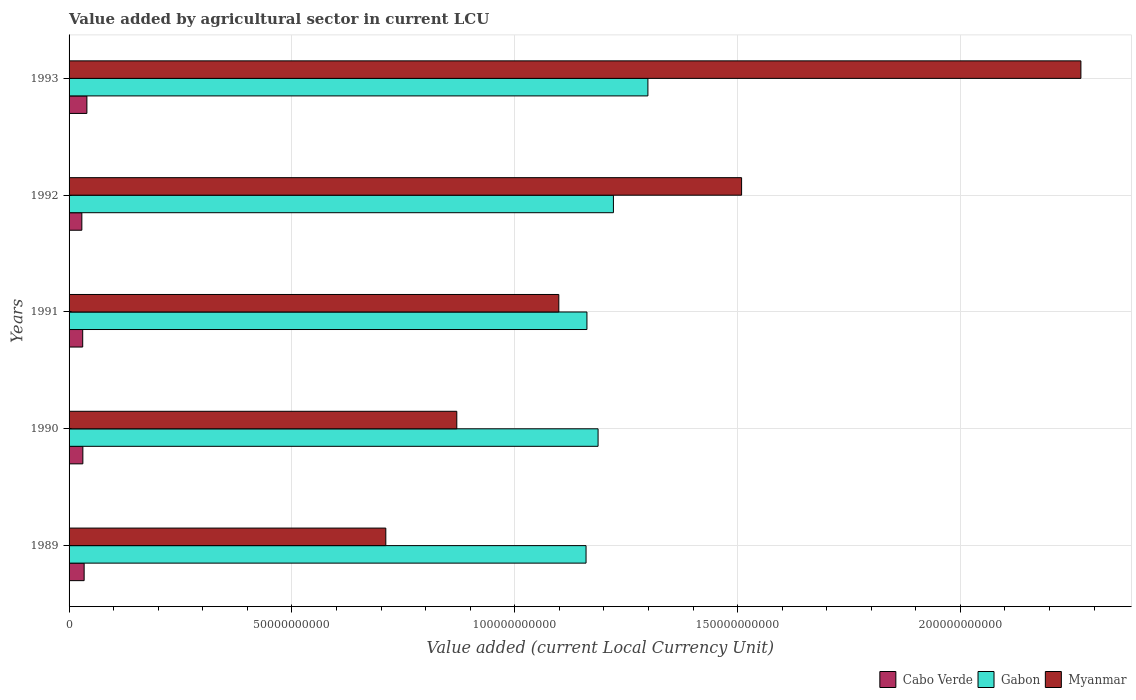How many different coloured bars are there?
Keep it short and to the point. 3. How many bars are there on the 5th tick from the top?
Make the answer very short. 3. How many bars are there on the 3rd tick from the bottom?
Offer a very short reply. 3. What is the value added by agricultural sector in Myanmar in 1991?
Your answer should be very brief. 1.10e+11. Across all years, what is the maximum value added by agricultural sector in Cabo Verde?
Offer a very short reply. 4.00e+09. Across all years, what is the minimum value added by agricultural sector in Myanmar?
Ensure brevity in your answer.  7.11e+1. In which year was the value added by agricultural sector in Cabo Verde maximum?
Provide a short and direct response. 1993. What is the total value added by agricultural sector in Myanmar in the graph?
Ensure brevity in your answer.  6.46e+11. What is the difference between the value added by agricultural sector in Cabo Verde in 1989 and that in 1990?
Keep it short and to the point. 2.88e+08. What is the difference between the value added by agricultural sector in Gabon in 1993 and the value added by agricultural sector in Cabo Verde in 1989?
Offer a very short reply. 1.26e+11. What is the average value added by agricultural sector in Cabo Verde per year?
Your response must be concise. 3.28e+09. In the year 1989, what is the difference between the value added by agricultural sector in Gabon and value added by agricultural sector in Cabo Verde?
Ensure brevity in your answer.  1.13e+11. What is the ratio of the value added by agricultural sector in Cabo Verde in 1992 to that in 1993?
Make the answer very short. 0.72. Is the value added by agricultural sector in Cabo Verde in 1989 less than that in 1993?
Give a very brief answer. Yes. Is the difference between the value added by agricultural sector in Gabon in 1990 and 1993 greater than the difference between the value added by agricultural sector in Cabo Verde in 1990 and 1993?
Provide a short and direct response. No. What is the difference between the highest and the second highest value added by agricultural sector in Cabo Verde?
Provide a succinct answer. 6.17e+08. What is the difference between the highest and the lowest value added by agricultural sector in Gabon?
Ensure brevity in your answer.  1.39e+1. Is the sum of the value added by agricultural sector in Cabo Verde in 1992 and 1993 greater than the maximum value added by agricultural sector in Myanmar across all years?
Provide a short and direct response. No. What does the 3rd bar from the top in 1991 represents?
Offer a very short reply. Cabo Verde. What does the 3rd bar from the bottom in 1991 represents?
Your response must be concise. Myanmar. Is it the case that in every year, the sum of the value added by agricultural sector in Cabo Verde and value added by agricultural sector in Myanmar is greater than the value added by agricultural sector in Gabon?
Make the answer very short. No. Are all the bars in the graph horizontal?
Offer a very short reply. Yes. Are the values on the major ticks of X-axis written in scientific E-notation?
Your response must be concise. No. Does the graph contain any zero values?
Keep it short and to the point. No. How are the legend labels stacked?
Offer a very short reply. Horizontal. What is the title of the graph?
Offer a terse response. Value added by agricultural sector in current LCU. Does "South Sudan" appear as one of the legend labels in the graph?
Your answer should be compact. No. What is the label or title of the X-axis?
Ensure brevity in your answer.  Value added (current Local Currency Unit). What is the label or title of the Y-axis?
Provide a succinct answer. Years. What is the Value added (current Local Currency Unit) in Cabo Verde in 1989?
Offer a very short reply. 3.38e+09. What is the Value added (current Local Currency Unit) in Gabon in 1989?
Offer a terse response. 1.16e+11. What is the Value added (current Local Currency Unit) of Myanmar in 1989?
Keep it short and to the point. 7.11e+1. What is the Value added (current Local Currency Unit) in Cabo Verde in 1990?
Provide a succinct answer. 3.09e+09. What is the Value added (current Local Currency Unit) in Gabon in 1990?
Offer a terse response. 1.19e+11. What is the Value added (current Local Currency Unit) in Myanmar in 1990?
Offer a very short reply. 8.70e+1. What is the Value added (current Local Currency Unit) of Cabo Verde in 1991?
Keep it short and to the point. 3.06e+09. What is the Value added (current Local Currency Unit) in Gabon in 1991?
Make the answer very short. 1.16e+11. What is the Value added (current Local Currency Unit) of Myanmar in 1991?
Ensure brevity in your answer.  1.10e+11. What is the Value added (current Local Currency Unit) of Cabo Verde in 1992?
Offer a very short reply. 2.87e+09. What is the Value added (current Local Currency Unit) of Gabon in 1992?
Provide a succinct answer. 1.22e+11. What is the Value added (current Local Currency Unit) in Myanmar in 1992?
Give a very brief answer. 1.51e+11. What is the Value added (current Local Currency Unit) of Cabo Verde in 1993?
Offer a very short reply. 4.00e+09. What is the Value added (current Local Currency Unit) of Gabon in 1993?
Your answer should be compact. 1.30e+11. What is the Value added (current Local Currency Unit) of Myanmar in 1993?
Your answer should be very brief. 2.27e+11. Across all years, what is the maximum Value added (current Local Currency Unit) of Cabo Verde?
Your answer should be very brief. 4.00e+09. Across all years, what is the maximum Value added (current Local Currency Unit) in Gabon?
Your response must be concise. 1.30e+11. Across all years, what is the maximum Value added (current Local Currency Unit) of Myanmar?
Your response must be concise. 2.27e+11. Across all years, what is the minimum Value added (current Local Currency Unit) in Cabo Verde?
Give a very brief answer. 2.87e+09. Across all years, what is the minimum Value added (current Local Currency Unit) of Gabon?
Give a very brief answer. 1.16e+11. Across all years, what is the minimum Value added (current Local Currency Unit) in Myanmar?
Give a very brief answer. 7.11e+1. What is the total Value added (current Local Currency Unit) of Cabo Verde in the graph?
Your response must be concise. 1.64e+1. What is the total Value added (current Local Currency Unit) of Gabon in the graph?
Offer a terse response. 6.03e+11. What is the total Value added (current Local Currency Unit) in Myanmar in the graph?
Ensure brevity in your answer.  6.46e+11. What is the difference between the Value added (current Local Currency Unit) in Cabo Verde in 1989 and that in 1990?
Your answer should be very brief. 2.88e+08. What is the difference between the Value added (current Local Currency Unit) in Gabon in 1989 and that in 1990?
Your answer should be compact. -2.70e+09. What is the difference between the Value added (current Local Currency Unit) in Myanmar in 1989 and that in 1990?
Make the answer very short. -1.59e+1. What is the difference between the Value added (current Local Currency Unit) of Cabo Verde in 1989 and that in 1991?
Your answer should be very brief. 3.22e+08. What is the difference between the Value added (current Local Currency Unit) in Gabon in 1989 and that in 1991?
Offer a terse response. -2.00e+08. What is the difference between the Value added (current Local Currency Unit) of Myanmar in 1989 and that in 1991?
Offer a terse response. -3.88e+1. What is the difference between the Value added (current Local Currency Unit) of Cabo Verde in 1989 and that in 1992?
Your answer should be compact. 5.16e+08. What is the difference between the Value added (current Local Currency Unit) of Gabon in 1989 and that in 1992?
Make the answer very short. -6.14e+09. What is the difference between the Value added (current Local Currency Unit) in Myanmar in 1989 and that in 1992?
Your answer should be very brief. -7.98e+1. What is the difference between the Value added (current Local Currency Unit) of Cabo Verde in 1989 and that in 1993?
Offer a terse response. -6.17e+08. What is the difference between the Value added (current Local Currency Unit) in Gabon in 1989 and that in 1993?
Make the answer very short. -1.39e+1. What is the difference between the Value added (current Local Currency Unit) of Myanmar in 1989 and that in 1993?
Offer a very short reply. -1.56e+11. What is the difference between the Value added (current Local Currency Unit) of Cabo Verde in 1990 and that in 1991?
Give a very brief answer. 3.41e+07. What is the difference between the Value added (current Local Currency Unit) of Gabon in 1990 and that in 1991?
Offer a terse response. 2.50e+09. What is the difference between the Value added (current Local Currency Unit) in Myanmar in 1990 and that in 1991?
Your answer should be very brief. -2.29e+1. What is the difference between the Value added (current Local Currency Unit) in Cabo Verde in 1990 and that in 1992?
Your answer should be compact. 2.28e+08. What is the difference between the Value added (current Local Currency Unit) in Gabon in 1990 and that in 1992?
Offer a very short reply. -3.44e+09. What is the difference between the Value added (current Local Currency Unit) in Myanmar in 1990 and that in 1992?
Ensure brevity in your answer.  -6.39e+1. What is the difference between the Value added (current Local Currency Unit) of Cabo Verde in 1990 and that in 1993?
Make the answer very short. -9.05e+08. What is the difference between the Value added (current Local Currency Unit) of Gabon in 1990 and that in 1993?
Provide a succinct answer. -1.12e+1. What is the difference between the Value added (current Local Currency Unit) in Myanmar in 1990 and that in 1993?
Ensure brevity in your answer.  -1.40e+11. What is the difference between the Value added (current Local Currency Unit) of Cabo Verde in 1991 and that in 1992?
Make the answer very short. 1.94e+08. What is the difference between the Value added (current Local Currency Unit) in Gabon in 1991 and that in 1992?
Ensure brevity in your answer.  -5.94e+09. What is the difference between the Value added (current Local Currency Unit) in Myanmar in 1991 and that in 1992?
Make the answer very short. -4.10e+1. What is the difference between the Value added (current Local Currency Unit) in Cabo Verde in 1991 and that in 1993?
Your answer should be very brief. -9.39e+08. What is the difference between the Value added (current Local Currency Unit) of Gabon in 1991 and that in 1993?
Offer a very short reply. -1.37e+1. What is the difference between the Value added (current Local Currency Unit) of Myanmar in 1991 and that in 1993?
Offer a very short reply. -1.17e+11. What is the difference between the Value added (current Local Currency Unit) in Cabo Verde in 1992 and that in 1993?
Your response must be concise. -1.13e+09. What is the difference between the Value added (current Local Currency Unit) in Gabon in 1992 and that in 1993?
Offer a very short reply. -7.74e+09. What is the difference between the Value added (current Local Currency Unit) in Myanmar in 1992 and that in 1993?
Offer a terse response. -7.61e+1. What is the difference between the Value added (current Local Currency Unit) of Cabo Verde in 1989 and the Value added (current Local Currency Unit) of Gabon in 1990?
Provide a short and direct response. -1.15e+11. What is the difference between the Value added (current Local Currency Unit) in Cabo Verde in 1989 and the Value added (current Local Currency Unit) in Myanmar in 1990?
Keep it short and to the point. -8.36e+1. What is the difference between the Value added (current Local Currency Unit) in Gabon in 1989 and the Value added (current Local Currency Unit) in Myanmar in 1990?
Provide a succinct answer. 2.90e+1. What is the difference between the Value added (current Local Currency Unit) of Cabo Verde in 1989 and the Value added (current Local Currency Unit) of Gabon in 1991?
Make the answer very short. -1.13e+11. What is the difference between the Value added (current Local Currency Unit) in Cabo Verde in 1989 and the Value added (current Local Currency Unit) in Myanmar in 1991?
Keep it short and to the point. -1.07e+11. What is the difference between the Value added (current Local Currency Unit) of Gabon in 1989 and the Value added (current Local Currency Unit) of Myanmar in 1991?
Offer a terse response. 6.11e+09. What is the difference between the Value added (current Local Currency Unit) of Cabo Verde in 1989 and the Value added (current Local Currency Unit) of Gabon in 1992?
Provide a short and direct response. -1.19e+11. What is the difference between the Value added (current Local Currency Unit) in Cabo Verde in 1989 and the Value added (current Local Currency Unit) in Myanmar in 1992?
Provide a short and direct response. -1.48e+11. What is the difference between the Value added (current Local Currency Unit) of Gabon in 1989 and the Value added (current Local Currency Unit) of Myanmar in 1992?
Offer a very short reply. -3.49e+1. What is the difference between the Value added (current Local Currency Unit) in Cabo Verde in 1989 and the Value added (current Local Currency Unit) in Gabon in 1993?
Make the answer very short. -1.26e+11. What is the difference between the Value added (current Local Currency Unit) of Cabo Verde in 1989 and the Value added (current Local Currency Unit) of Myanmar in 1993?
Your answer should be compact. -2.24e+11. What is the difference between the Value added (current Local Currency Unit) in Gabon in 1989 and the Value added (current Local Currency Unit) in Myanmar in 1993?
Offer a very short reply. -1.11e+11. What is the difference between the Value added (current Local Currency Unit) in Cabo Verde in 1990 and the Value added (current Local Currency Unit) in Gabon in 1991?
Provide a succinct answer. -1.13e+11. What is the difference between the Value added (current Local Currency Unit) of Cabo Verde in 1990 and the Value added (current Local Currency Unit) of Myanmar in 1991?
Offer a terse response. -1.07e+11. What is the difference between the Value added (current Local Currency Unit) of Gabon in 1990 and the Value added (current Local Currency Unit) of Myanmar in 1991?
Keep it short and to the point. 8.81e+09. What is the difference between the Value added (current Local Currency Unit) of Cabo Verde in 1990 and the Value added (current Local Currency Unit) of Gabon in 1992?
Your response must be concise. -1.19e+11. What is the difference between the Value added (current Local Currency Unit) in Cabo Verde in 1990 and the Value added (current Local Currency Unit) in Myanmar in 1992?
Provide a short and direct response. -1.48e+11. What is the difference between the Value added (current Local Currency Unit) of Gabon in 1990 and the Value added (current Local Currency Unit) of Myanmar in 1992?
Your response must be concise. -3.22e+1. What is the difference between the Value added (current Local Currency Unit) of Cabo Verde in 1990 and the Value added (current Local Currency Unit) of Gabon in 1993?
Your response must be concise. -1.27e+11. What is the difference between the Value added (current Local Currency Unit) of Cabo Verde in 1990 and the Value added (current Local Currency Unit) of Myanmar in 1993?
Offer a terse response. -2.24e+11. What is the difference between the Value added (current Local Currency Unit) of Gabon in 1990 and the Value added (current Local Currency Unit) of Myanmar in 1993?
Provide a short and direct response. -1.08e+11. What is the difference between the Value added (current Local Currency Unit) of Cabo Verde in 1991 and the Value added (current Local Currency Unit) of Gabon in 1992?
Your answer should be very brief. -1.19e+11. What is the difference between the Value added (current Local Currency Unit) of Cabo Verde in 1991 and the Value added (current Local Currency Unit) of Myanmar in 1992?
Offer a terse response. -1.48e+11. What is the difference between the Value added (current Local Currency Unit) in Gabon in 1991 and the Value added (current Local Currency Unit) in Myanmar in 1992?
Ensure brevity in your answer.  -3.47e+1. What is the difference between the Value added (current Local Currency Unit) in Cabo Verde in 1991 and the Value added (current Local Currency Unit) in Gabon in 1993?
Give a very brief answer. -1.27e+11. What is the difference between the Value added (current Local Currency Unit) of Cabo Verde in 1991 and the Value added (current Local Currency Unit) of Myanmar in 1993?
Provide a short and direct response. -2.24e+11. What is the difference between the Value added (current Local Currency Unit) of Gabon in 1991 and the Value added (current Local Currency Unit) of Myanmar in 1993?
Ensure brevity in your answer.  -1.11e+11. What is the difference between the Value added (current Local Currency Unit) of Cabo Verde in 1992 and the Value added (current Local Currency Unit) of Gabon in 1993?
Keep it short and to the point. -1.27e+11. What is the difference between the Value added (current Local Currency Unit) of Cabo Verde in 1992 and the Value added (current Local Currency Unit) of Myanmar in 1993?
Give a very brief answer. -2.24e+11. What is the difference between the Value added (current Local Currency Unit) in Gabon in 1992 and the Value added (current Local Currency Unit) in Myanmar in 1993?
Your answer should be very brief. -1.05e+11. What is the average Value added (current Local Currency Unit) in Cabo Verde per year?
Provide a succinct answer. 3.28e+09. What is the average Value added (current Local Currency Unit) of Gabon per year?
Ensure brevity in your answer.  1.21e+11. What is the average Value added (current Local Currency Unit) in Myanmar per year?
Provide a succinct answer. 1.29e+11. In the year 1989, what is the difference between the Value added (current Local Currency Unit) in Cabo Verde and Value added (current Local Currency Unit) in Gabon?
Make the answer very short. -1.13e+11. In the year 1989, what is the difference between the Value added (current Local Currency Unit) of Cabo Verde and Value added (current Local Currency Unit) of Myanmar?
Ensure brevity in your answer.  -6.77e+1. In the year 1989, what is the difference between the Value added (current Local Currency Unit) in Gabon and Value added (current Local Currency Unit) in Myanmar?
Make the answer very short. 4.49e+1. In the year 1990, what is the difference between the Value added (current Local Currency Unit) of Cabo Verde and Value added (current Local Currency Unit) of Gabon?
Ensure brevity in your answer.  -1.16e+11. In the year 1990, what is the difference between the Value added (current Local Currency Unit) in Cabo Verde and Value added (current Local Currency Unit) in Myanmar?
Your answer should be compact. -8.39e+1. In the year 1990, what is the difference between the Value added (current Local Currency Unit) in Gabon and Value added (current Local Currency Unit) in Myanmar?
Provide a short and direct response. 3.17e+1. In the year 1991, what is the difference between the Value added (current Local Currency Unit) in Cabo Verde and Value added (current Local Currency Unit) in Gabon?
Your response must be concise. -1.13e+11. In the year 1991, what is the difference between the Value added (current Local Currency Unit) of Cabo Verde and Value added (current Local Currency Unit) of Myanmar?
Give a very brief answer. -1.07e+11. In the year 1991, what is the difference between the Value added (current Local Currency Unit) of Gabon and Value added (current Local Currency Unit) of Myanmar?
Offer a terse response. 6.31e+09. In the year 1992, what is the difference between the Value added (current Local Currency Unit) in Cabo Verde and Value added (current Local Currency Unit) in Gabon?
Your response must be concise. -1.19e+11. In the year 1992, what is the difference between the Value added (current Local Currency Unit) in Cabo Verde and Value added (current Local Currency Unit) in Myanmar?
Your answer should be very brief. -1.48e+11. In the year 1992, what is the difference between the Value added (current Local Currency Unit) in Gabon and Value added (current Local Currency Unit) in Myanmar?
Provide a succinct answer. -2.88e+1. In the year 1993, what is the difference between the Value added (current Local Currency Unit) in Cabo Verde and Value added (current Local Currency Unit) in Gabon?
Keep it short and to the point. -1.26e+11. In the year 1993, what is the difference between the Value added (current Local Currency Unit) in Cabo Verde and Value added (current Local Currency Unit) in Myanmar?
Your answer should be very brief. -2.23e+11. In the year 1993, what is the difference between the Value added (current Local Currency Unit) of Gabon and Value added (current Local Currency Unit) of Myanmar?
Ensure brevity in your answer.  -9.72e+1. What is the ratio of the Value added (current Local Currency Unit) of Cabo Verde in 1989 to that in 1990?
Offer a terse response. 1.09. What is the ratio of the Value added (current Local Currency Unit) in Gabon in 1989 to that in 1990?
Ensure brevity in your answer.  0.98. What is the ratio of the Value added (current Local Currency Unit) in Myanmar in 1989 to that in 1990?
Your answer should be very brief. 0.82. What is the ratio of the Value added (current Local Currency Unit) of Cabo Verde in 1989 to that in 1991?
Ensure brevity in your answer.  1.11. What is the ratio of the Value added (current Local Currency Unit) of Myanmar in 1989 to that in 1991?
Your answer should be very brief. 0.65. What is the ratio of the Value added (current Local Currency Unit) in Cabo Verde in 1989 to that in 1992?
Provide a short and direct response. 1.18. What is the ratio of the Value added (current Local Currency Unit) in Gabon in 1989 to that in 1992?
Your answer should be very brief. 0.95. What is the ratio of the Value added (current Local Currency Unit) in Myanmar in 1989 to that in 1992?
Give a very brief answer. 0.47. What is the ratio of the Value added (current Local Currency Unit) in Cabo Verde in 1989 to that in 1993?
Provide a short and direct response. 0.85. What is the ratio of the Value added (current Local Currency Unit) in Gabon in 1989 to that in 1993?
Offer a terse response. 0.89. What is the ratio of the Value added (current Local Currency Unit) in Myanmar in 1989 to that in 1993?
Give a very brief answer. 0.31. What is the ratio of the Value added (current Local Currency Unit) of Cabo Verde in 1990 to that in 1991?
Give a very brief answer. 1.01. What is the ratio of the Value added (current Local Currency Unit) of Gabon in 1990 to that in 1991?
Make the answer very short. 1.02. What is the ratio of the Value added (current Local Currency Unit) of Myanmar in 1990 to that in 1991?
Keep it short and to the point. 0.79. What is the ratio of the Value added (current Local Currency Unit) of Cabo Verde in 1990 to that in 1992?
Offer a terse response. 1.08. What is the ratio of the Value added (current Local Currency Unit) of Gabon in 1990 to that in 1992?
Offer a terse response. 0.97. What is the ratio of the Value added (current Local Currency Unit) in Myanmar in 1990 to that in 1992?
Make the answer very short. 0.58. What is the ratio of the Value added (current Local Currency Unit) in Cabo Verde in 1990 to that in 1993?
Ensure brevity in your answer.  0.77. What is the ratio of the Value added (current Local Currency Unit) of Gabon in 1990 to that in 1993?
Give a very brief answer. 0.91. What is the ratio of the Value added (current Local Currency Unit) in Myanmar in 1990 to that in 1993?
Provide a short and direct response. 0.38. What is the ratio of the Value added (current Local Currency Unit) of Cabo Verde in 1991 to that in 1992?
Ensure brevity in your answer.  1.07. What is the ratio of the Value added (current Local Currency Unit) in Gabon in 1991 to that in 1992?
Your answer should be compact. 0.95. What is the ratio of the Value added (current Local Currency Unit) in Myanmar in 1991 to that in 1992?
Your answer should be compact. 0.73. What is the ratio of the Value added (current Local Currency Unit) of Cabo Verde in 1991 to that in 1993?
Give a very brief answer. 0.77. What is the ratio of the Value added (current Local Currency Unit) in Gabon in 1991 to that in 1993?
Ensure brevity in your answer.  0.89. What is the ratio of the Value added (current Local Currency Unit) of Myanmar in 1991 to that in 1993?
Keep it short and to the point. 0.48. What is the ratio of the Value added (current Local Currency Unit) in Cabo Verde in 1992 to that in 1993?
Ensure brevity in your answer.  0.72. What is the ratio of the Value added (current Local Currency Unit) in Gabon in 1992 to that in 1993?
Provide a short and direct response. 0.94. What is the ratio of the Value added (current Local Currency Unit) in Myanmar in 1992 to that in 1993?
Provide a succinct answer. 0.66. What is the difference between the highest and the second highest Value added (current Local Currency Unit) in Cabo Verde?
Ensure brevity in your answer.  6.17e+08. What is the difference between the highest and the second highest Value added (current Local Currency Unit) of Gabon?
Offer a terse response. 7.74e+09. What is the difference between the highest and the second highest Value added (current Local Currency Unit) of Myanmar?
Your response must be concise. 7.61e+1. What is the difference between the highest and the lowest Value added (current Local Currency Unit) in Cabo Verde?
Give a very brief answer. 1.13e+09. What is the difference between the highest and the lowest Value added (current Local Currency Unit) in Gabon?
Offer a very short reply. 1.39e+1. What is the difference between the highest and the lowest Value added (current Local Currency Unit) of Myanmar?
Keep it short and to the point. 1.56e+11. 